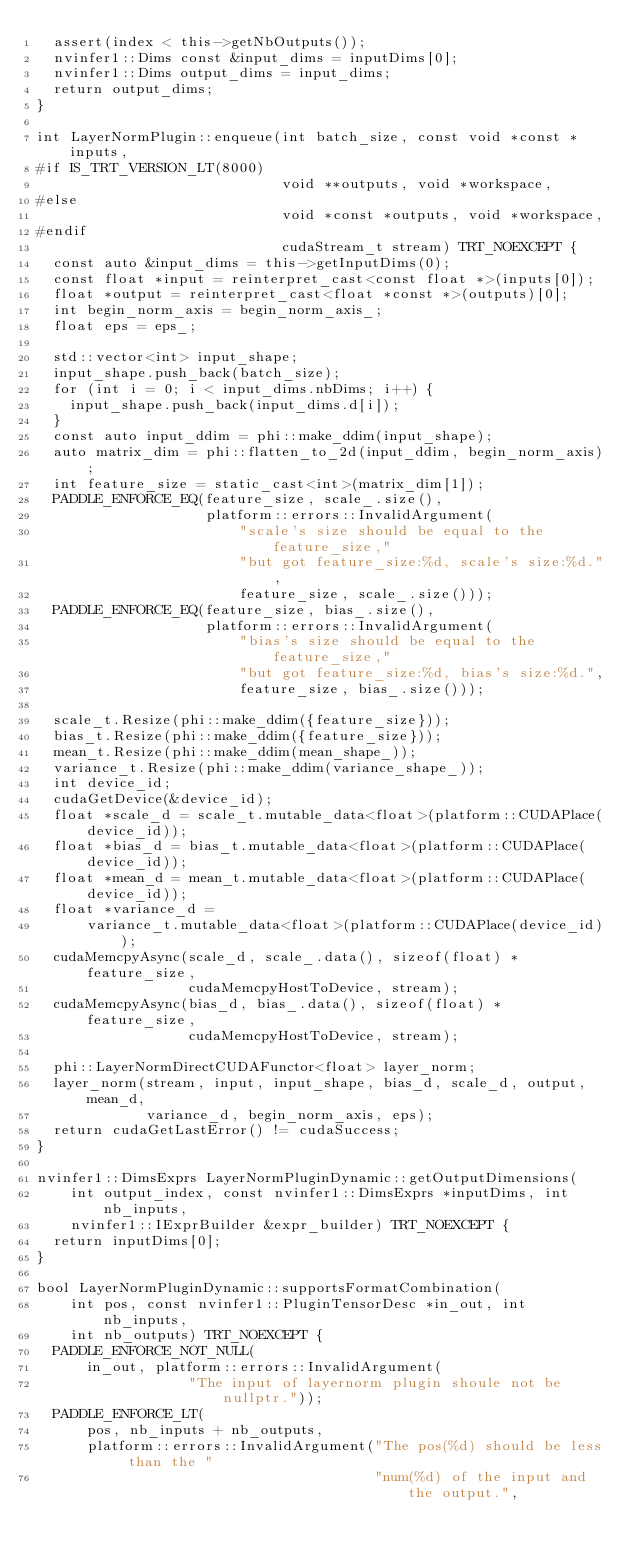Convert code to text. <code><loc_0><loc_0><loc_500><loc_500><_Cuda_>  assert(index < this->getNbOutputs());
  nvinfer1::Dims const &input_dims = inputDims[0];
  nvinfer1::Dims output_dims = input_dims;
  return output_dims;
}

int LayerNormPlugin::enqueue(int batch_size, const void *const *inputs,
#if IS_TRT_VERSION_LT(8000)
                             void **outputs, void *workspace,
#else
                             void *const *outputs, void *workspace,
#endif
                             cudaStream_t stream) TRT_NOEXCEPT {
  const auto &input_dims = this->getInputDims(0);
  const float *input = reinterpret_cast<const float *>(inputs[0]);
  float *output = reinterpret_cast<float *const *>(outputs)[0];
  int begin_norm_axis = begin_norm_axis_;
  float eps = eps_;

  std::vector<int> input_shape;
  input_shape.push_back(batch_size);
  for (int i = 0; i < input_dims.nbDims; i++) {
    input_shape.push_back(input_dims.d[i]);
  }
  const auto input_ddim = phi::make_ddim(input_shape);
  auto matrix_dim = phi::flatten_to_2d(input_ddim, begin_norm_axis);
  int feature_size = static_cast<int>(matrix_dim[1]);
  PADDLE_ENFORCE_EQ(feature_size, scale_.size(),
                    platform::errors::InvalidArgument(
                        "scale's size should be equal to the feature_size,"
                        "but got feature_size:%d, scale's size:%d.",
                        feature_size, scale_.size()));
  PADDLE_ENFORCE_EQ(feature_size, bias_.size(),
                    platform::errors::InvalidArgument(
                        "bias's size should be equal to the feature_size,"
                        "but got feature_size:%d, bias's size:%d.",
                        feature_size, bias_.size()));

  scale_t.Resize(phi::make_ddim({feature_size}));
  bias_t.Resize(phi::make_ddim({feature_size}));
  mean_t.Resize(phi::make_ddim(mean_shape_));
  variance_t.Resize(phi::make_ddim(variance_shape_));
  int device_id;
  cudaGetDevice(&device_id);
  float *scale_d = scale_t.mutable_data<float>(platform::CUDAPlace(device_id));
  float *bias_d = bias_t.mutable_data<float>(platform::CUDAPlace(device_id));
  float *mean_d = mean_t.mutable_data<float>(platform::CUDAPlace(device_id));
  float *variance_d =
      variance_t.mutable_data<float>(platform::CUDAPlace(device_id));
  cudaMemcpyAsync(scale_d, scale_.data(), sizeof(float) * feature_size,
                  cudaMemcpyHostToDevice, stream);
  cudaMemcpyAsync(bias_d, bias_.data(), sizeof(float) * feature_size,
                  cudaMemcpyHostToDevice, stream);

  phi::LayerNormDirectCUDAFunctor<float> layer_norm;
  layer_norm(stream, input, input_shape, bias_d, scale_d, output, mean_d,
             variance_d, begin_norm_axis, eps);
  return cudaGetLastError() != cudaSuccess;
}

nvinfer1::DimsExprs LayerNormPluginDynamic::getOutputDimensions(
    int output_index, const nvinfer1::DimsExprs *inputDims, int nb_inputs,
    nvinfer1::IExprBuilder &expr_builder) TRT_NOEXCEPT {
  return inputDims[0];
}

bool LayerNormPluginDynamic::supportsFormatCombination(
    int pos, const nvinfer1::PluginTensorDesc *in_out, int nb_inputs,
    int nb_outputs) TRT_NOEXCEPT {
  PADDLE_ENFORCE_NOT_NULL(
      in_out, platform::errors::InvalidArgument(
                  "The input of layernorm plugin shoule not be nullptr."));
  PADDLE_ENFORCE_LT(
      pos, nb_inputs + nb_outputs,
      platform::errors::InvalidArgument("The pos(%d) should be less than the "
                                        "num(%d) of the input and the output.",</code> 